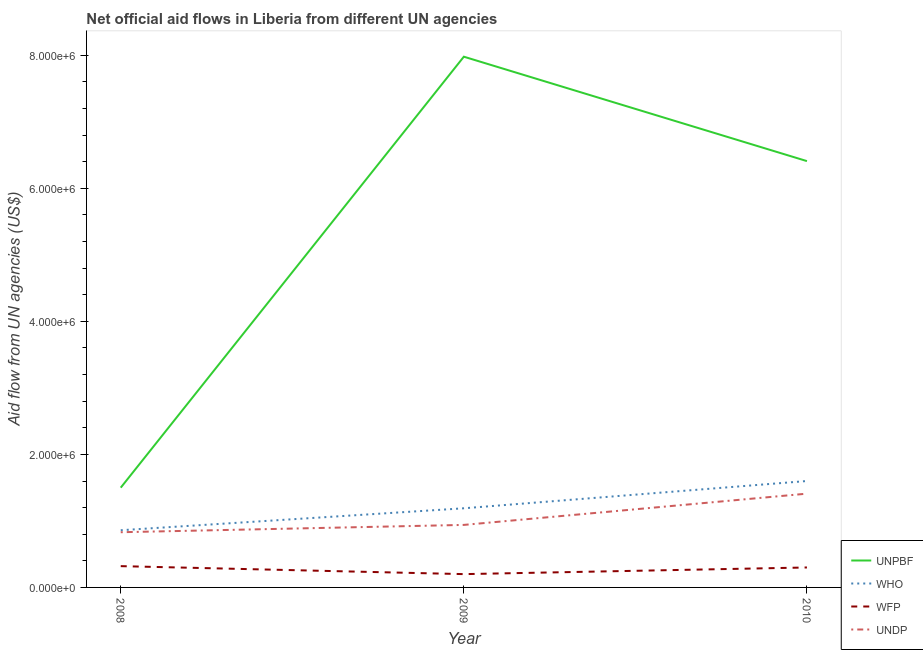Does the line corresponding to amount of aid given by who intersect with the line corresponding to amount of aid given by wfp?
Your response must be concise. No. What is the amount of aid given by wfp in 2009?
Your answer should be very brief. 2.00e+05. Across all years, what is the maximum amount of aid given by who?
Ensure brevity in your answer.  1.60e+06. Across all years, what is the minimum amount of aid given by who?
Give a very brief answer. 8.60e+05. What is the total amount of aid given by wfp in the graph?
Make the answer very short. 8.20e+05. What is the difference between the amount of aid given by undp in 2009 and that in 2010?
Give a very brief answer. -4.70e+05. What is the difference between the amount of aid given by who in 2009 and the amount of aid given by unpbf in 2008?
Your answer should be very brief. -3.10e+05. What is the average amount of aid given by who per year?
Provide a short and direct response. 1.22e+06. In the year 2008, what is the difference between the amount of aid given by who and amount of aid given by undp?
Your answer should be very brief. 3.00e+04. In how many years, is the amount of aid given by undp greater than 2000000 US$?
Provide a succinct answer. 0. What is the ratio of the amount of aid given by who in 2009 to that in 2010?
Provide a succinct answer. 0.74. What is the difference between the highest and the lowest amount of aid given by who?
Give a very brief answer. 7.40e+05. Is the sum of the amount of aid given by who in 2009 and 2010 greater than the maximum amount of aid given by wfp across all years?
Ensure brevity in your answer.  Yes. Is it the case that in every year, the sum of the amount of aid given by undp and amount of aid given by wfp is greater than the sum of amount of aid given by unpbf and amount of aid given by who?
Your answer should be very brief. No. Does the amount of aid given by undp monotonically increase over the years?
Make the answer very short. Yes. Is the amount of aid given by undp strictly greater than the amount of aid given by who over the years?
Ensure brevity in your answer.  No. How many lines are there?
Make the answer very short. 4. What is the difference between two consecutive major ticks on the Y-axis?
Offer a very short reply. 2.00e+06. Are the values on the major ticks of Y-axis written in scientific E-notation?
Your answer should be very brief. Yes. Where does the legend appear in the graph?
Offer a terse response. Bottom right. How many legend labels are there?
Offer a terse response. 4. What is the title of the graph?
Give a very brief answer. Net official aid flows in Liberia from different UN agencies. Does "Macroeconomic management" appear as one of the legend labels in the graph?
Provide a succinct answer. No. What is the label or title of the X-axis?
Offer a terse response. Year. What is the label or title of the Y-axis?
Provide a succinct answer. Aid flow from UN agencies (US$). What is the Aid flow from UN agencies (US$) in UNPBF in 2008?
Provide a short and direct response. 1.50e+06. What is the Aid flow from UN agencies (US$) of WHO in 2008?
Your answer should be very brief. 8.60e+05. What is the Aid flow from UN agencies (US$) of UNDP in 2008?
Your answer should be compact. 8.30e+05. What is the Aid flow from UN agencies (US$) of UNPBF in 2009?
Make the answer very short. 7.98e+06. What is the Aid flow from UN agencies (US$) of WHO in 2009?
Make the answer very short. 1.19e+06. What is the Aid flow from UN agencies (US$) in UNDP in 2009?
Keep it short and to the point. 9.40e+05. What is the Aid flow from UN agencies (US$) of UNPBF in 2010?
Make the answer very short. 6.41e+06. What is the Aid flow from UN agencies (US$) of WHO in 2010?
Provide a succinct answer. 1.60e+06. What is the Aid flow from UN agencies (US$) in WFP in 2010?
Keep it short and to the point. 3.00e+05. What is the Aid flow from UN agencies (US$) in UNDP in 2010?
Provide a short and direct response. 1.41e+06. Across all years, what is the maximum Aid flow from UN agencies (US$) of UNPBF?
Provide a succinct answer. 7.98e+06. Across all years, what is the maximum Aid flow from UN agencies (US$) in WHO?
Offer a very short reply. 1.60e+06. Across all years, what is the maximum Aid flow from UN agencies (US$) in UNDP?
Give a very brief answer. 1.41e+06. Across all years, what is the minimum Aid flow from UN agencies (US$) of UNPBF?
Your answer should be compact. 1.50e+06. Across all years, what is the minimum Aid flow from UN agencies (US$) of WHO?
Your answer should be very brief. 8.60e+05. Across all years, what is the minimum Aid flow from UN agencies (US$) in UNDP?
Provide a succinct answer. 8.30e+05. What is the total Aid flow from UN agencies (US$) in UNPBF in the graph?
Ensure brevity in your answer.  1.59e+07. What is the total Aid flow from UN agencies (US$) in WHO in the graph?
Provide a short and direct response. 3.65e+06. What is the total Aid flow from UN agencies (US$) in WFP in the graph?
Offer a very short reply. 8.20e+05. What is the total Aid flow from UN agencies (US$) of UNDP in the graph?
Ensure brevity in your answer.  3.18e+06. What is the difference between the Aid flow from UN agencies (US$) in UNPBF in 2008 and that in 2009?
Your response must be concise. -6.48e+06. What is the difference between the Aid flow from UN agencies (US$) of WHO in 2008 and that in 2009?
Offer a very short reply. -3.30e+05. What is the difference between the Aid flow from UN agencies (US$) in UNPBF in 2008 and that in 2010?
Ensure brevity in your answer.  -4.91e+06. What is the difference between the Aid flow from UN agencies (US$) in WHO in 2008 and that in 2010?
Offer a terse response. -7.40e+05. What is the difference between the Aid flow from UN agencies (US$) in UNDP in 2008 and that in 2010?
Your response must be concise. -5.80e+05. What is the difference between the Aid flow from UN agencies (US$) of UNPBF in 2009 and that in 2010?
Make the answer very short. 1.57e+06. What is the difference between the Aid flow from UN agencies (US$) of WHO in 2009 and that in 2010?
Ensure brevity in your answer.  -4.10e+05. What is the difference between the Aid flow from UN agencies (US$) in WFP in 2009 and that in 2010?
Your response must be concise. -1.00e+05. What is the difference between the Aid flow from UN agencies (US$) of UNDP in 2009 and that in 2010?
Offer a terse response. -4.70e+05. What is the difference between the Aid flow from UN agencies (US$) of UNPBF in 2008 and the Aid flow from UN agencies (US$) of WHO in 2009?
Your answer should be very brief. 3.10e+05. What is the difference between the Aid flow from UN agencies (US$) in UNPBF in 2008 and the Aid flow from UN agencies (US$) in WFP in 2009?
Offer a very short reply. 1.30e+06. What is the difference between the Aid flow from UN agencies (US$) in UNPBF in 2008 and the Aid flow from UN agencies (US$) in UNDP in 2009?
Your answer should be compact. 5.60e+05. What is the difference between the Aid flow from UN agencies (US$) of WHO in 2008 and the Aid flow from UN agencies (US$) of UNDP in 2009?
Offer a very short reply. -8.00e+04. What is the difference between the Aid flow from UN agencies (US$) of WFP in 2008 and the Aid flow from UN agencies (US$) of UNDP in 2009?
Give a very brief answer. -6.20e+05. What is the difference between the Aid flow from UN agencies (US$) in UNPBF in 2008 and the Aid flow from UN agencies (US$) in WFP in 2010?
Give a very brief answer. 1.20e+06. What is the difference between the Aid flow from UN agencies (US$) in WHO in 2008 and the Aid flow from UN agencies (US$) in WFP in 2010?
Provide a succinct answer. 5.60e+05. What is the difference between the Aid flow from UN agencies (US$) in WHO in 2008 and the Aid flow from UN agencies (US$) in UNDP in 2010?
Provide a succinct answer. -5.50e+05. What is the difference between the Aid flow from UN agencies (US$) of WFP in 2008 and the Aid flow from UN agencies (US$) of UNDP in 2010?
Provide a succinct answer. -1.09e+06. What is the difference between the Aid flow from UN agencies (US$) of UNPBF in 2009 and the Aid flow from UN agencies (US$) of WHO in 2010?
Offer a very short reply. 6.38e+06. What is the difference between the Aid flow from UN agencies (US$) in UNPBF in 2009 and the Aid flow from UN agencies (US$) in WFP in 2010?
Give a very brief answer. 7.68e+06. What is the difference between the Aid flow from UN agencies (US$) in UNPBF in 2009 and the Aid flow from UN agencies (US$) in UNDP in 2010?
Give a very brief answer. 6.57e+06. What is the difference between the Aid flow from UN agencies (US$) of WHO in 2009 and the Aid flow from UN agencies (US$) of WFP in 2010?
Your answer should be compact. 8.90e+05. What is the difference between the Aid flow from UN agencies (US$) in WHO in 2009 and the Aid flow from UN agencies (US$) in UNDP in 2010?
Offer a very short reply. -2.20e+05. What is the difference between the Aid flow from UN agencies (US$) of WFP in 2009 and the Aid flow from UN agencies (US$) of UNDP in 2010?
Keep it short and to the point. -1.21e+06. What is the average Aid flow from UN agencies (US$) in UNPBF per year?
Provide a succinct answer. 5.30e+06. What is the average Aid flow from UN agencies (US$) of WHO per year?
Provide a short and direct response. 1.22e+06. What is the average Aid flow from UN agencies (US$) in WFP per year?
Offer a very short reply. 2.73e+05. What is the average Aid flow from UN agencies (US$) of UNDP per year?
Provide a succinct answer. 1.06e+06. In the year 2008, what is the difference between the Aid flow from UN agencies (US$) in UNPBF and Aid flow from UN agencies (US$) in WHO?
Your response must be concise. 6.40e+05. In the year 2008, what is the difference between the Aid flow from UN agencies (US$) of UNPBF and Aid flow from UN agencies (US$) of WFP?
Your answer should be very brief. 1.18e+06. In the year 2008, what is the difference between the Aid flow from UN agencies (US$) in UNPBF and Aid flow from UN agencies (US$) in UNDP?
Offer a very short reply. 6.70e+05. In the year 2008, what is the difference between the Aid flow from UN agencies (US$) in WHO and Aid flow from UN agencies (US$) in WFP?
Ensure brevity in your answer.  5.40e+05. In the year 2008, what is the difference between the Aid flow from UN agencies (US$) in WFP and Aid flow from UN agencies (US$) in UNDP?
Your answer should be very brief. -5.10e+05. In the year 2009, what is the difference between the Aid flow from UN agencies (US$) of UNPBF and Aid flow from UN agencies (US$) of WHO?
Give a very brief answer. 6.79e+06. In the year 2009, what is the difference between the Aid flow from UN agencies (US$) in UNPBF and Aid flow from UN agencies (US$) in WFP?
Ensure brevity in your answer.  7.78e+06. In the year 2009, what is the difference between the Aid flow from UN agencies (US$) in UNPBF and Aid flow from UN agencies (US$) in UNDP?
Your response must be concise. 7.04e+06. In the year 2009, what is the difference between the Aid flow from UN agencies (US$) in WHO and Aid flow from UN agencies (US$) in WFP?
Your answer should be compact. 9.90e+05. In the year 2009, what is the difference between the Aid flow from UN agencies (US$) in WFP and Aid flow from UN agencies (US$) in UNDP?
Offer a terse response. -7.40e+05. In the year 2010, what is the difference between the Aid flow from UN agencies (US$) of UNPBF and Aid flow from UN agencies (US$) of WHO?
Ensure brevity in your answer.  4.81e+06. In the year 2010, what is the difference between the Aid flow from UN agencies (US$) of UNPBF and Aid flow from UN agencies (US$) of WFP?
Ensure brevity in your answer.  6.11e+06. In the year 2010, what is the difference between the Aid flow from UN agencies (US$) of WHO and Aid flow from UN agencies (US$) of WFP?
Offer a terse response. 1.30e+06. In the year 2010, what is the difference between the Aid flow from UN agencies (US$) of WFP and Aid flow from UN agencies (US$) of UNDP?
Offer a terse response. -1.11e+06. What is the ratio of the Aid flow from UN agencies (US$) of UNPBF in 2008 to that in 2009?
Ensure brevity in your answer.  0.19. What is the ratio of the Aid flow from UN agencies (US$) in WHO in 2008 to that in 2009?
Your answer should be compact. 0.72. What is the ratio of the Aid flow from UN agencies (US$) of UNDP in 2008 to that in 2009?
Provide a succinct answer. 0.88. What is the ratio of the Aid flow from UN agencies (US$) of UNPBF in 2008 to that in 2010?
Give a very brief answer. 0.23. What is the ratio of the Aid flow from UN agencies (US$) in WHO in 2008 to that in 2010?
Offer a very short reply. 0.54. What is the ratio of the Aid flow from UN agencies (US$) in WFP in 2008 to that in 2010?
Give a very brief answer. 1.07. What is the ratio of the Aid flow from UN agencies (US$) of UNDP in 2008 to that in 2010?
Provide a succinct answer. 0.59. What is the ratio of the Aid flow from UN agencies (US$) in UNPBF in 2009 to that in 2010?
Provide a succinct answer. 1.24. What is the ratio of the Aid flow from UN agencies (US$) in WHO in 2009 to that in 2010?
Ensure brevity in your answer.  0.74. What is the difference between the highest and the second highest Aid flow from UN agencies (US$) in UNPBF?
Make the answer very short. 1.57e+06. What is the difference between the highest and the second highest Aid flow from UN agencies (US$) in WHO?
Provide a short and direct response. 4.10e+05. What is the difference between the highest and the lowest Aid flow from UN agencies (US$) in UNPBF?
Provide a short and direct response. 6.48e+06. What is the difference between the highest and the lowest Aid flow from UN agencies (US$) of WHO?
Keep it short and to the point. 7.40e+05. What is the difference between the highest and the lowest Aid flow from UN agencies (US$) of UNDP?
Keep it short and to the point. 5.80e+05. 